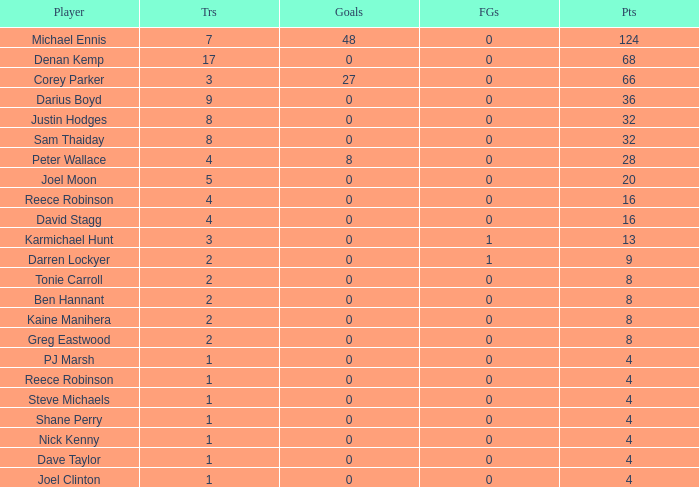Would you be able to parse every entry in this table? {'header': ['Player', 'Trs', 'Goals', 'FGs', 'Pts'], 'rows': [['Michael Ennis', '7', '48', '0', '124'], ['Denan Kemp', '17', '0', '0', '68'], ['Corey Parker', '3', '27', '0', '66'], ['Darius Boyd', '9', '0', '0', '36'], ['Justin Hodges', '8', '0', '0', '32'], ['Sam Thaiday', '8', '0', '0', '32'], ['Peter Wallace', '4', '8', '0', '28'], ['Joel Moon', '5', '0', '0', '20'], ['Reece Robinson', '4', '0', '0', '16'], ['David Stagg', '4', '0', '0', '16'], ['Karmichael Hunt', '3', '0', '1', '13'], ['Darren Lockyer', '2', '0', '1', '9'], ['Tonie Carroll', '2', '0', '0', '8'], ['Ben Hannant', '2', '0', '0', '8'], ['Kaine Manihera', '2', '0', '0', '8'], ['Greg Eastwood', '2', '0', '0', '8'], ['PJ Marsh', '1', '0', '0', '4'], ['Reece Robinson', '1', '0', '0', '4'], ['Steve Michaels', '1', '0', '0', '4'], ['Shane Perry', '1', '0', '0', '4'], ['Nick Kenny', '1', '0', '0', '4'], ['Dave Taylor', '1', '0', '0', '4'], ['Joel Clinton', '1', '0', '0', '4']]} What is the number of goals Dave Taylor, who has more than 1 tries, has? None. 